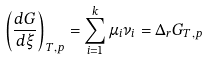<formula> <loc_0><loc_0><loc_500><loc_500>\left ( { \frac { d G } { d \xi } } \right ) _ { T , p } = \sum _ { i = 1 } ^ { k } \mu _ { i } \nu _ { i } = \Delta _ { r } G _ { T , p }</formula> 